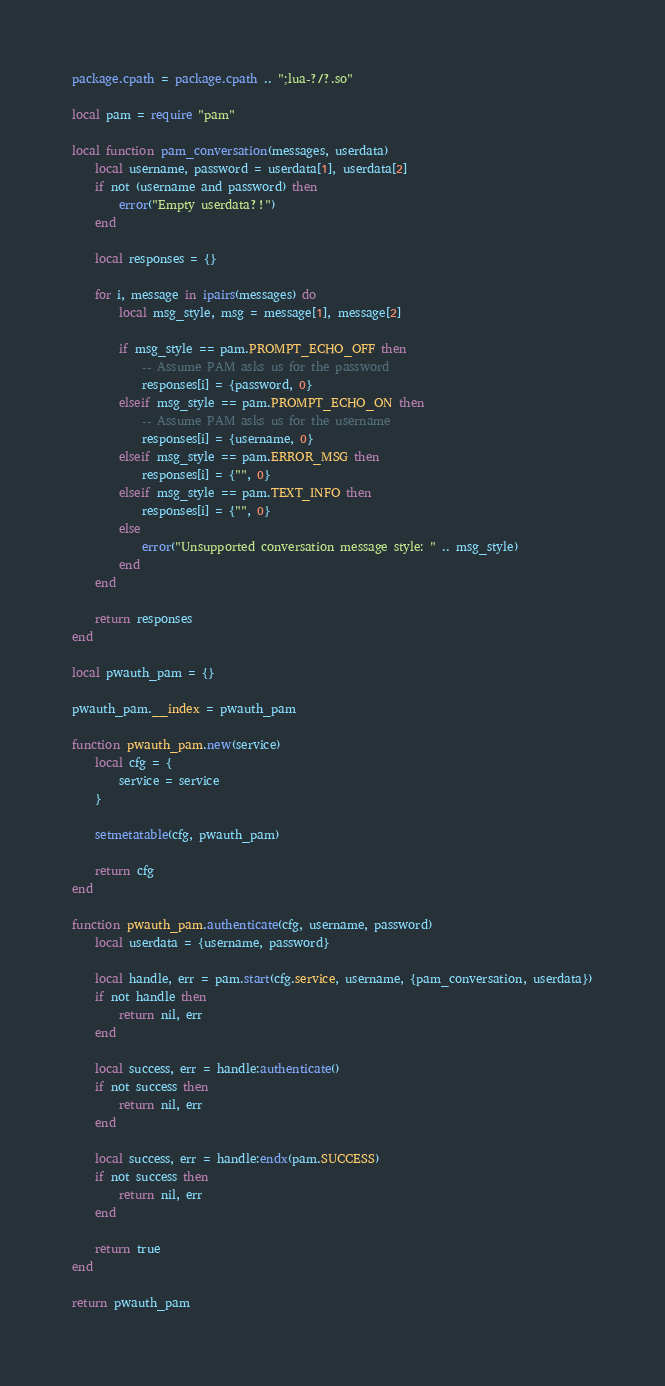Convert code to text. <code><loc_0><loc_0><loc_500><loc_500><_Lua_>package.cpath = package.cpath .. ";lua-?/?.so"

local pam = require "pam"

local function pam_conversation(messages, userdata)
	local username, password = userdata[1], userdata[2]
	if not (username and password) then
		error("Empty userdata?!")
	end

	local responses = {}

	for i, message in ipairs(messages) do
		local msg_style, msg = message[1], message[2]

		if msg_style == pam.PROMPT_ECHO_OFF then
			-- Assume PAM asks us for the password
			responses[i] = {password, 0}
		elseif msg_style == pam.PROMPT_ECHO_ON then
			-- Assume PAM asks us for the username
			responses[i] = {username, 0}
		elseif msg_style == pam.ERROR_MSG then
			responses[i] = {"", 0}
		elseif msg_style == pam.TEXT_INFO then
			responses[i] = {"", 0}
		else
			error("Unsupported conversation message style: " .. msg_style)
		end
	end

	return responses
end

local pwauth_pam = {}

pwauth_pam.__index = pwauth_pam

function pwauth_pam.new(service)
	local cfg = {
		service = service
	}

	setmetatable(cfg, pwauth_pam)

	return cfg
end

function pwauth_pam.authenticate(cfg, username, password)
	local userdata = {username, password}

	local handle, err = pam.start(cfg.service, username, {pam_conversation, userdata})
	if not handle then
		return nil, err
	end

	local success, err = handle:authenticate()
	if not success then
		return nil, err
	end

	local success, err = handle:endx(pam.SUCCESS)
	if not success then
		return nil, err
	end

	return true
end

return pwauth_pam
</code> 